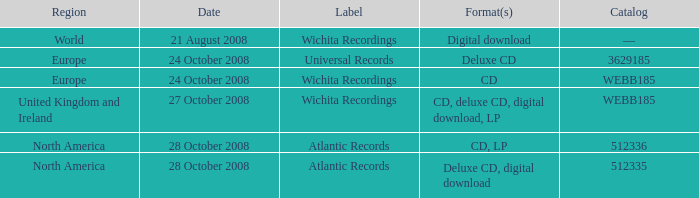Give me the full table as a dictionary. {'header': ['Region', 'Date', 'Label', 'Format(s)', 'Catalog'], 'rows': [['World', '21 August 2008', 'Wichita Recordings', 'Digital download', '—'], ['Europe', '24 October 2008', 'Universal Records', 'Deluxe CD', '3629185'], ['Europe', '24 October 2008', 'Wichita Recordings', 'CD', 'WEBB185'], ['United Kingdom and Ireland', '27 October 2008', 'Wichita Recordings', 'CD, deluxe CD, digital download, LP', 'WEBB185'], ['North America', '28 October 2008', 'Atlantic Records', 'CD, LP', '512336'], ['North America', '28 October 2008', 'Atlantic Records', 'Deluxe CD, digital download', '512335']]} What are the formats connected to the atlantic records label, catalog number 512336? CD, LP. 